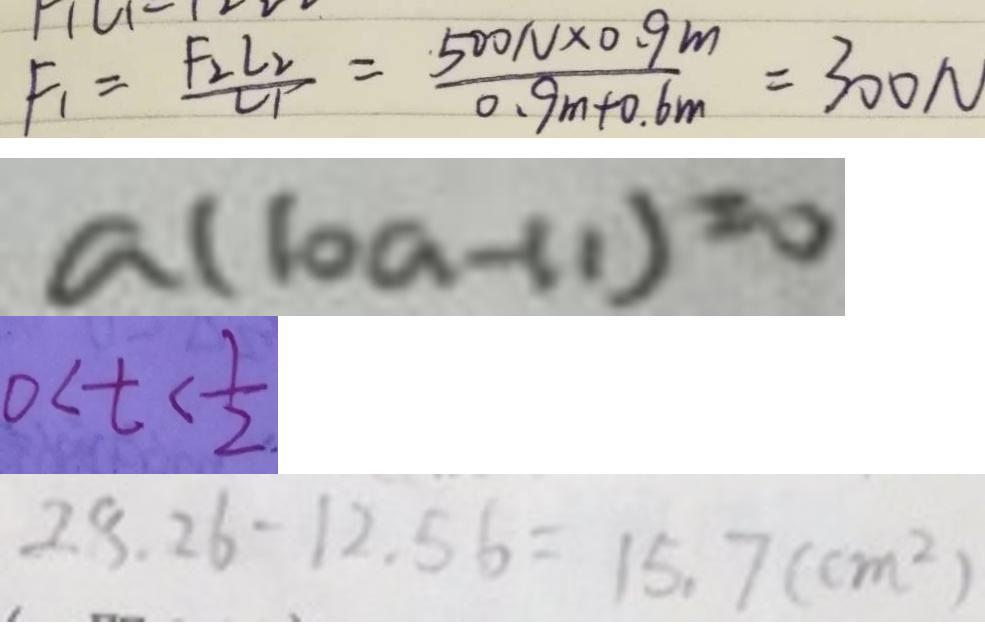Convert formula to latex. <formula><loc_0><loc_0><loc_500><loc_500>F _ { 1 } = \frac { F _ { 2 } L _ { 2 } } { L _ { 1 } } = \frac { 5 0 0 N \times 0 . 9 m } { 0 . 9 m + 0 . 6 m } = 3 0 0 N 
 a ( 1 0 a - 1 1 ) = 0 
 0 < t < \frac { 1 } { 2 } 
 2 8 . 2 6 - 1 2 . 5 6 = 1 5 . 7 ( c m ^ { 2 } )</formula> 